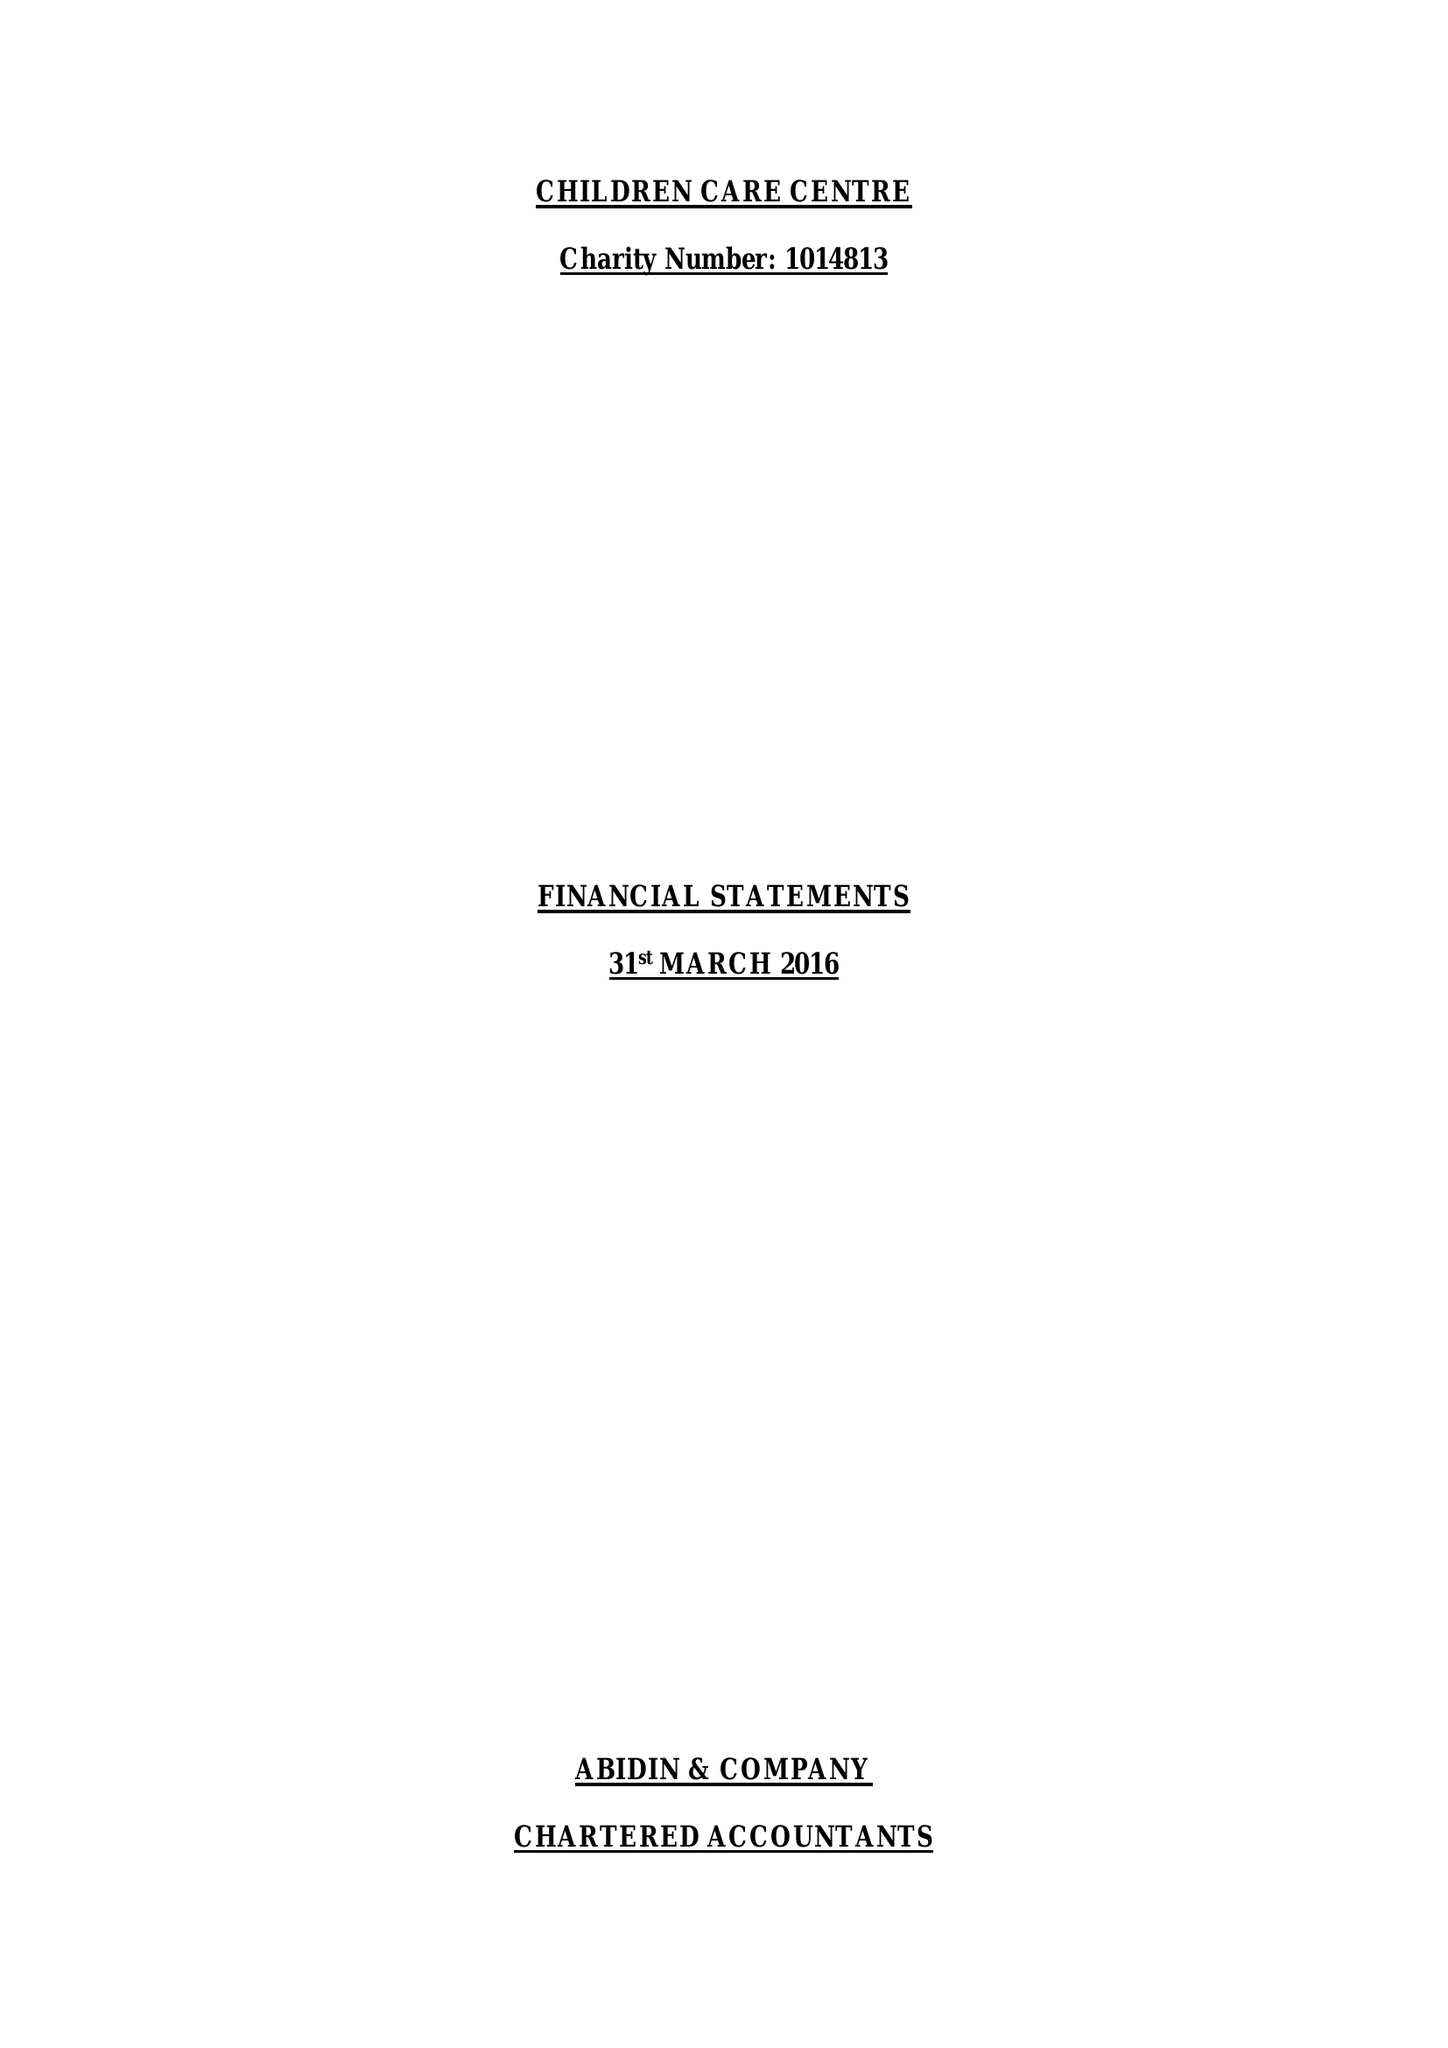What is the value for the charity_name?
Answer the question using a single word or phrase. Children Care Centre 